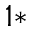Convert formula to latex. <formula><loc_0><loc_0><loc_500><loc_500>^ { 1 * }</formula> 